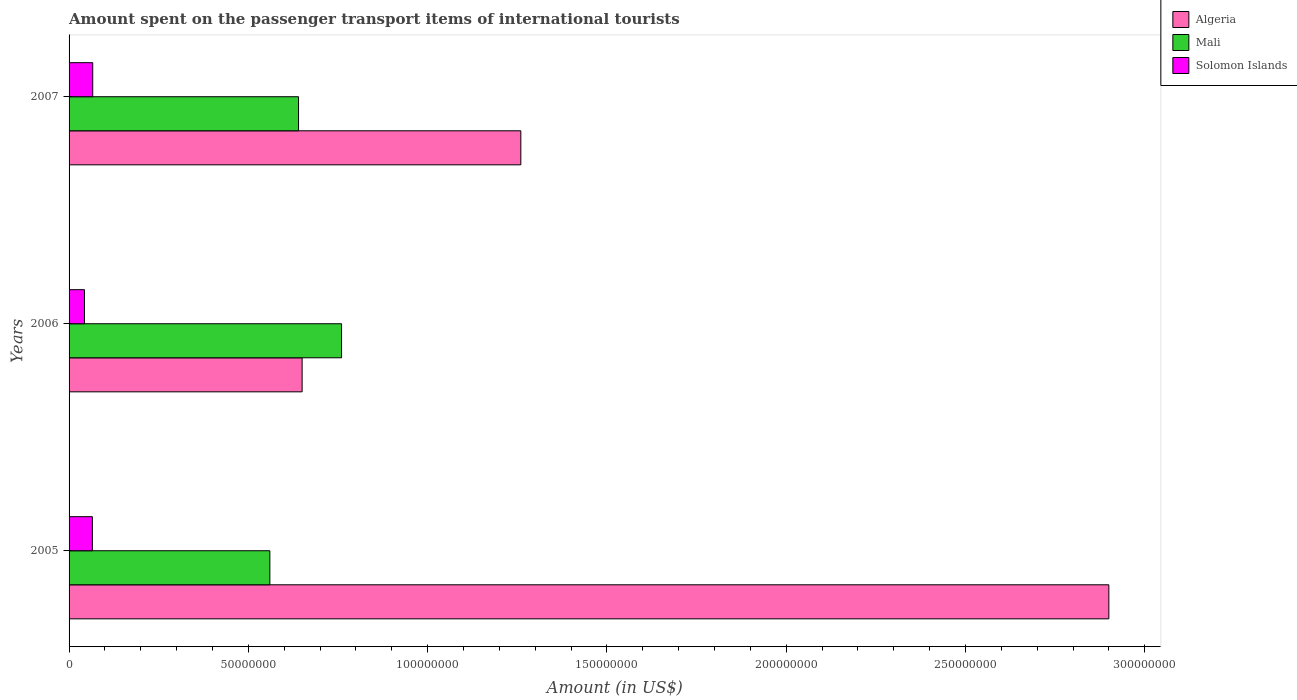How many different coloured bars are there?
Make the answer very short. 3. Are the number of bars per tick equal to the number of legend labels?
Give a very brief answer. Yes. How many bars are there on the 2nd tick from the bottom?
Make the answer very short. 3. What is the amount spent on the passenger transport items of international tourists in Solomon Islands in 2006?
Offer a very short reply. 4.30e+06. Across all years, what is the maximum amount spent on the passenger transport items of international tourists in Mali?
Make the answer very short. 7.60e+07. Across all years, what is the minimum amount spent on the passenger transport items of international tourists in Mali?
Offer a terse response. 5.60e+07. In which year was the amount spent on the passenger transport items of international tourists in Mali maximum?
Your answer should be very brief. 2006. In which year was the amount spent on the passenger transport items of international tourists in Mali minimum?
Your answer should be compact. 2005. What is the total amount spent on the passenger transport items of international tourists in Mali in the graph?
Keep it short and to the point. 1.96e+08. What is the difference between the amount spent on the passenger transport items of international tourists in Algeria in 2006 and that in 2007?
Provide a succinct answer. -6.10e+07. What is the difference between the amount spent on the passenger transport items of international tourists in Solomon Islands in 2006 and the amount spent on the passenger transport items of international tourists in Mali in 2007?
Your answer should be very brief. -5.97e+07. What is the average amount spent on the passenger transport items of international tourists in Solomon Islands per year?
Provide a succinct answer. 5.80e+06. In the year 2007, what is the difference between the amount spent on the passenger transport items of international tourists in Algeria and amount spent on the passenger transport items of international tourists in Mali?
Offer a terse response. 6.20e+07. What is the ratio of the amount spent on the passenger transport items of international tourists in Algeria in 2006 to that in 2007?
Make the answer very short. 0.52. Is the difference between the amount spent on the passenger transport items of international tourists in Algeria in 2005 and 2006 greater than the difference between the amount spent on the passenger transport items of international tourists in Mali in 2005 and 2006?
Your answer should be compact. Yes. What is the difference between the highest and the second highest amount spent on the passenger transport items of international tourists in Algeria?
Make the answer very short. 1.64e+08. What is the difference between the highest and the lowest amount spent on the passenger transport items of international tourists in Solomon Islands?
Make the answer very short. 2.30e+06. In how many years, is the amount spent on the passenger transport items of international tourists in Algeria greater than the average amount spent on the passenger transport items of international tourists in Algeria taken over all years?
Provide a succinct answer. 1. What does the 3rd bar from the top in 2006 represents?
Give a very brief answer. Algeria. What does the 3rd bar from the bottom in 2005 represents?
Your answer should be compact. Solomon Islands. Is it the case that in every year, the sum of the amount spent on the passenger transport items of international tourists in Solomon Islands and amount spent on the passenger transport items of international tourists in Algeria is greater than the amount spent on the passenger transport items of international tourists in Mali?
Offer a very short reply. No. Are all the bars in the graph horizontal?
Offer a terse response. Yes. Are the values on the major ticks of X-axis written in scientific E-notation?
Keep it short and to the point. No. Does the graph contain any zero values?
Your answer should be very brief. No. Does the graph contain grids?
Your response must be concise. No. Where does the legend appear in the graph?
Provide a succinct answer. Top right. How many legend labels are there?
Keep it short and to the point. 3. What is the title of the graph?
Give a very brief answer. Amount spent on the passenger transport items of international tourists. What is the label or title of the Y-axis?
Offer a very short reply. Years. What is the Amount (in US$) in Algeria in 2005?
Make the answer very short. 2.90e+08. What is the Amount (in US$) of Mali in 2005?
Make the answer very short. 5.60e+07. What is the Amount (in US$) in Solomon Islands in 2005?
Give a very brief answer. 6.50e+06. What is the Amount (in US$) of Algeria in 2006?
Ensure brevity in your answer.  6.50e+07. What is the Amount (in US$) of Mali in 2006?
Your response must be concise. 7.60e+07. What is the Amount (in US$) in Solomon Islands in 2006?
Give a very brief answer. 4.30e+06. What is the Amount (in US$) of Algeria in 2007?
Offer a very short reply. 1.26e+08. What is the Amount (in US$) in Mali in 2007?
Provide a succinct answer. 6.40e+07. What is the Amount (in US$) of Solomon Islands in 2007?
Give a very brief answer. 6.60e+06. Across all years, what is the maximum Amount (in US$) of Algeria?
Make the answer very short. 2.90e+08. Across all years, what is the maximum Amount (in US$) in Mali?
Ensure brevity in your answer.  7.60e+07. Across all years, what is the maximum Amount (in US$) of Solomon Islands?
Keep it short and to the point. 6.60e+06. Across all years, what is the minimum Amount (in US$) of Algeria?
Provide a short and direct response. 6.50e+07. Across all years, what is the minimum Amount (in US$) in Mali?
Provide a succinct answer. 5.60e+07. Across all years, what is the minimum Amount (in US$) of Solomon Islands?
Provide a succinct answer. 4.30e+06. What is the total Amount (in US$) of Algeria in the graph?
Ensure brevity in your answer.  4.81e+08. What is the total Amount (in US$) of Mali in the graph?
Provide a short and direct response. 1.96e+08. What is the total Amount (in US$) of Solomon Islands in the graph?
Offer a very short reply. 1.74e+07. What is the difference between the Amount (in US$) of Algeria in 2005 and that in 2006?
Provide a short and direct response. 2.25e+08. What is the difference between the Amount (in US$) of Mali in 2005 and that in 2006?
Make the answer very short. -2.00e+07. What is the difference between the Amount (in US$) of Solomon Islands in 2005 and that in 2006?
Offer a very short reply. 2.20e+06. What is the difference between the Amount (in US$) in Algeria in 2005 and that in 2007?
Keep it short and to the point. 1.64e+08. What is the difference between the Amount (in US$) of Mali in 2005 and that in 2007?
Make the answer very short. -8.00e+06. What is the difference between the Amount (in US$) in Solomon Islands in 2005 and that in 2007?
Keep it short and to the point. -1.00e+05. What is the difference between the Amount (in US$) in Algeria in 2006 and that in 2007?
Provide a succinct answer. -6.10e+07. What is the difference between the Amount (in US$) of Mali in 2006 and that in 2007?
Your answer should be very brief. 1.20e+07. What is the difference between the Amount (in US$) of Solomon Islands in 2006 and that in 2007?
Provide a short and direct response. -2.30e+06. What is the difference between the Amount (in US$) in Algeria in 2005 and the Amount (in US$) in Mali in 2006?
Give a very brief answer. 2.14e+08. What is the difference between the Amount (in US$) of Algeria in 2005 and the Amount (in US$) of Solomon Islands in 2006?
Provide a succinct answer. 2.86e+08. What is the difference between the Amount (in US$) of Mali in 2005 and the Amount (in US$) of Solomon Islands in 2006?
Provide a short and direct response. 5.17e+07. What is the difference between the Amount (in US$) of Algeria in 2005 and the Amount (in US$) of Mali in 2007?
Make the answer very short. 2.26e+08. What is the difference between the Amount (in US$) in Algeria in 2005 and the Amount (in US$) in Solomon Islands in 2007?
Your answer should be very brief. 2.83e+08. What is the difference between the Amount (in US$) in Mali in 2005 and the Amount (in US$) in Solomon Islands in 2007?
Offer a very short reply. 4.94e+07. What is the difference between the Amount (in US$) of Algeria in 2006 and the Amount (in US$) of Solomon Islands in 2007?
Offer a terse response. 5.84e+07. What is the difference between the Amount (in US$) in Mali in 2006 and the Amount (in US$) in Solomon Islands in 2007?
Your response must be concise. 6.94e+07. What is the average Amount (in US$) in Algeria per year?
Your answer should be compact. 1.60e+08. What is the average Amount (in US$) of Mali per year?
Give a very brief answer. 6.53e+07. What is the average Amount (in US$) in Solomon Islands per year?
Offer a very short reply. 5.80e+06. In the year 2005, what is the difference between the Amount (in US$) in Algeria and Amount (in US$) in Mali?
Your answer should be very brief. 2.34e+08. In the year 2005, what is the difference between the Amount (in US$) of Algeria and Amount (in US$) of Solomon Islands?
Offer a very short reply. 2.84e+08. In the year 2005, what is the difference between the Amount (in US$) in Mali and Amount (in US$) in Solomon Islands?
Provide a succinct answer. 4.95e+07. In the year 2006, what is the difference between the Amount (in US$) in Algeria and Amount (in US$) in Mali?
Offer a terse response. -1.10e+07. In the year 2006, what is the difference between the Amount (in US$) in Algeria and Amount (in US$) in Solomon Islands?
Make the answer very short. 6.07e+07. In the year 2006, what is the difference between the Amount (in US$) of Mali and Amount (in US$) of Solomon Islands?
Your response must be concise. 7.17e+07. In the year 2007, what is the difference between the Amount (in US$) of Algeria and Amount (in US$) of Mali?
Make the answer very short. 6.20e+07. In the year 2007, what is the difference between the Amount (in US$) in Algeria and Amount (in US$) in Solomon Islands?
Give a very brief answer. 1.19e+08. In the year 2007, what is the difference between the Amount (in US$) in Mali and Amount (in US$) in Solomon Islands?
Your answer should be very brief. 5.74e+07. What is the ratio of the Amount (in US$) in Algeria in 2005 to that in 2006?
Provide a succinct answer. 4.46. What is the ratio of the Amount (in US$) of Mali in 2005 to that in 2006?
Your answer should be very brief. 0.74. What is the ratio of the Amount (in US$) in Solomon Islands in 2005 to that in 2006?
Provide a succinct answer. 1.51. What is the ratio of the Amount (in US$) of Algeria in 2005 to that in 2007?
Your response must be concise. 2.3. What is the ratio of the Amount (in US$) in Solomon Islands in 2005 to that in 2007?
Provide a succinct answer. 0.98. What is the ratio of the Amount (in US$) in Algeria in 2006 to that in 2007?
Offer a terse response. 0.52. What is the ratio of the Amount (in US$) of Mali in 2006 to that in 2007?
Offer a terse response. 1.19. What is the ratio of the Amount (in US$) of Solomon Islands in 2006 to that in 2007?
Your answer should be compact. 0.65. What is the difference between the highest and the second highest Amount (in US$) in Algeria?
Provide a short and direct response. 1.64e+08. What is the difference between the highest and the lowest Amount (in US$) of Algeria?
Your answer should be compact. 2.25e+08. What is the difference between the highest and the lowest Amount (in US$) in Mali?
Provide a succinct answer. 2.00e+07. What is the difference between the highest and the lowest Amount (in US$) in Solomon Islands?
Ensure brevity in your answer.  2.30e+06. 